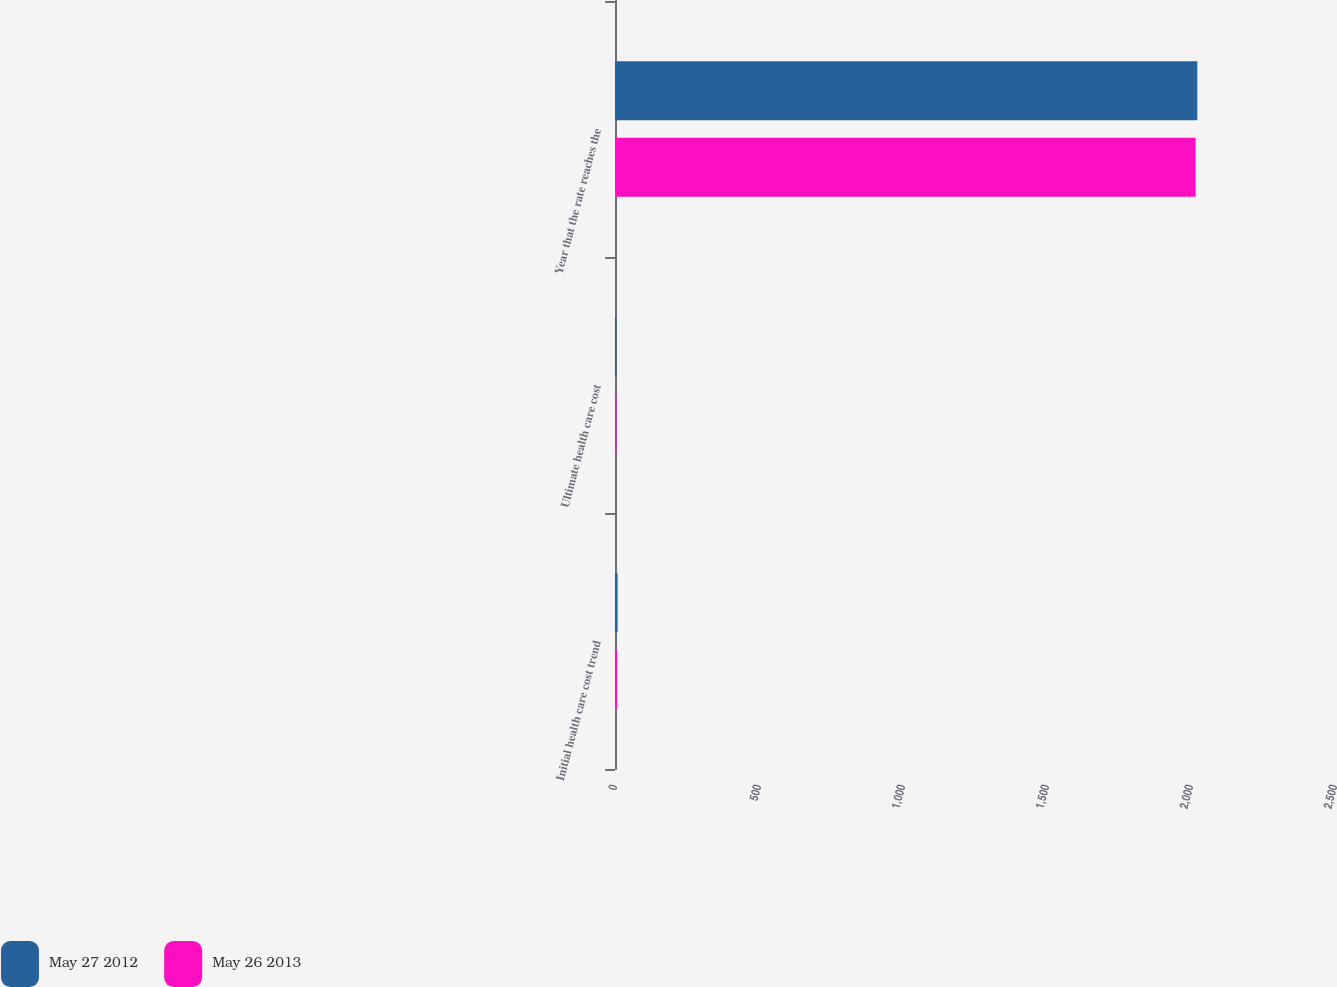Convert chart. <chart><loc_0><loc_0><loc_500><loc_500><stacked_bar_chart><ecel><fcel>Initial health care cost trend<fcel>Ultimate health care cost<fcel>Year that the rate reaches the<nl><fcel>May 27 2012<fcel>9<fcel>5<fcel>2022<nl><fcel>May 26 2013<fcel>7.5<fcel>5<fcel>2016<nl></chart> 